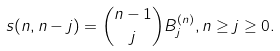<formula> <loc_0><loc_0><loc_500><loc_500>s ( n , n - j ) = \binom { n - 1 } { j } B _ { j } ^ { ( n ) } , n \geq j \geq 0 .</formula> 